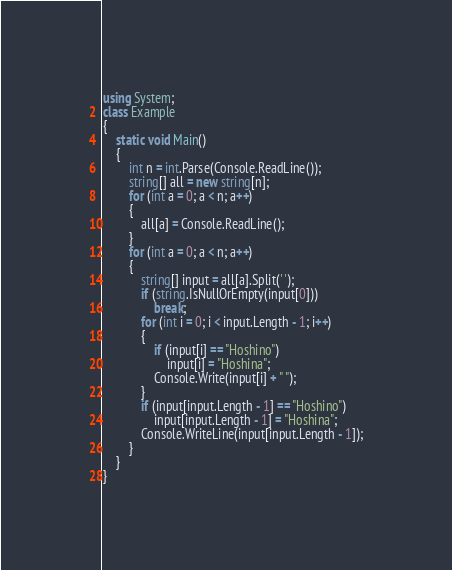Convert code to text. <code><loc_0><loc_0><loc_500><loc_500><_C#_>using System;
class Example
{
    static void Main()
    {
        int n = int.Parse(Console.ReadLine());
        string[] all = new string[n];
        for (int a = 0; a < n; a++)
        {
            all[a] = Console.ReadLine();
        }
        for (int a = 0; a < n; a++)
        {
            string[] input = all[a].Split(' ');
            if (string.IsNullOrEmpty(input[0]))
                break;
            for (int i = 0; i < input.Length - 1; i++)
            {
                if (input[i] == "Hoshino")
                    input[i] = "Hoshina";
                Console.Write(input[i] + " ");
            }
            if (input[input.Length - 1] == "Hoshino")
                input[input.Length - 1] = "Hoshina";
            Console.WriteLine(input[input.Length - 1]);
        }
    }
}</code> 